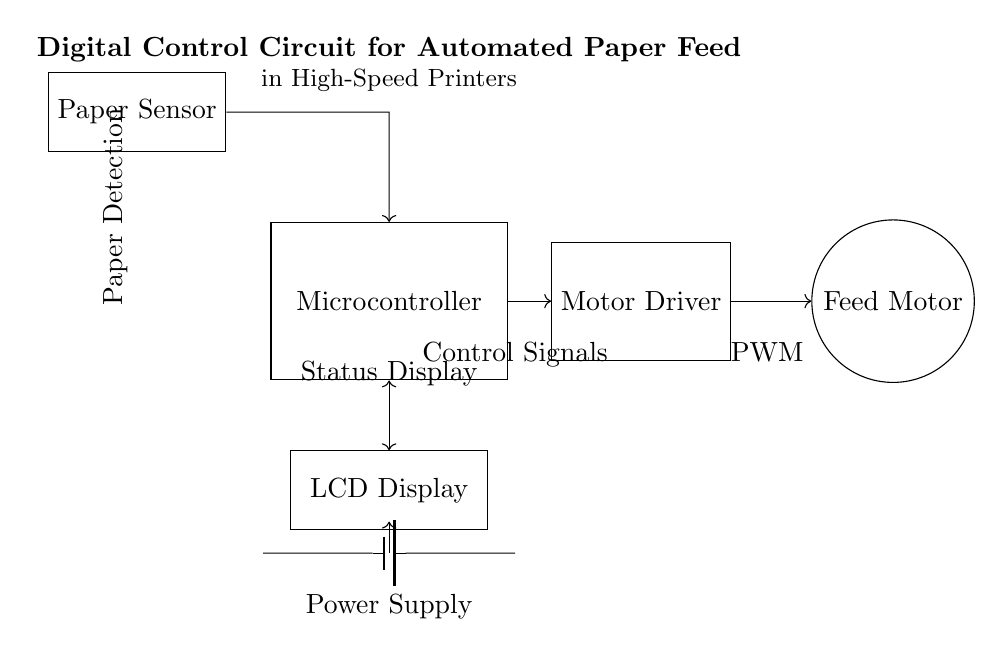What component detects paper in this circuit? The component that detects paper is labeled as "Paper Sensor," which is positioned at the top left corner of the circuit diagram.
Answer: Paper Sensor What is the function of the Microcontroller in this circuit? The Microcontroller processes signals from the Paper Sensor and sends control signals to the Motor Driver, facilitating the automation of paper feeding in the printer.
Answer: Control processing Which component provides power to the circuit? The Power Supply is the source supplying voltage to the circuit, represented by a battery symbol at the bottom.
Answer: Power Supply What type of control does the Motor Driver provide to the Feed Motor? The Motor Driver sends Pulse Width Modulation (PWM) signals to control the operation of the Feed Motor, enabling precise control of its speed and position.
Answer: PWM How are the Paper Sensor and Microcontroller connected? The Paper Sensor is connected to the Microcontroller with a directed arrow indicating one-way communication, where the sensor sends signals to the microcontroller for detection processing.
Answer: One-way arrow What type of display is included in the circuit for user interaction? The circuit includes an LCD Display component, which provides visual feedback and status information to the user regarding the paper feed process.
Answer: LCD Display Why is the connection from the Microcontroller to the LCD Display bidirectional? The bidirectional connection indicates that the Microcontroller can both send status information to the LCD and receive input or commands from it, allowing for interactive control.
Answer: Interactive communication 